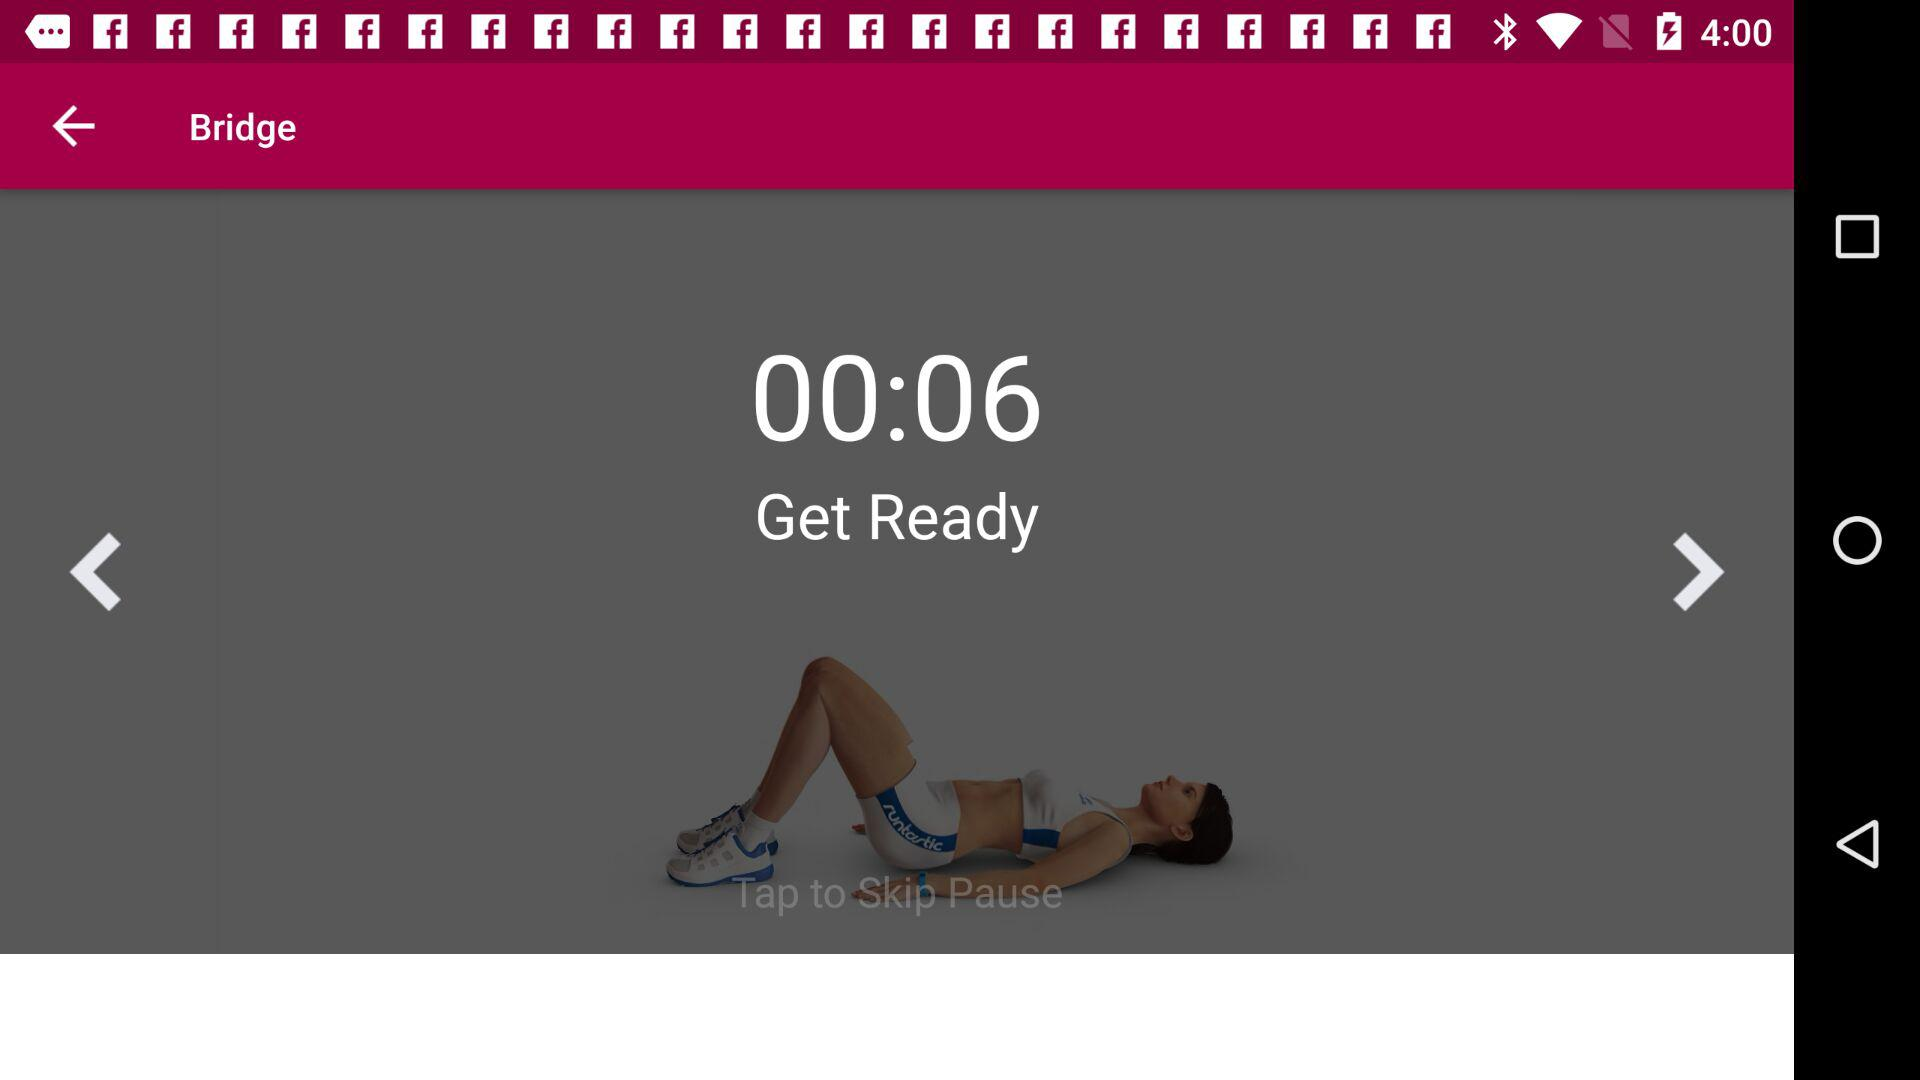In how many days do we have to do 32 exercises? You have to do 32 exercises in 7 days. 